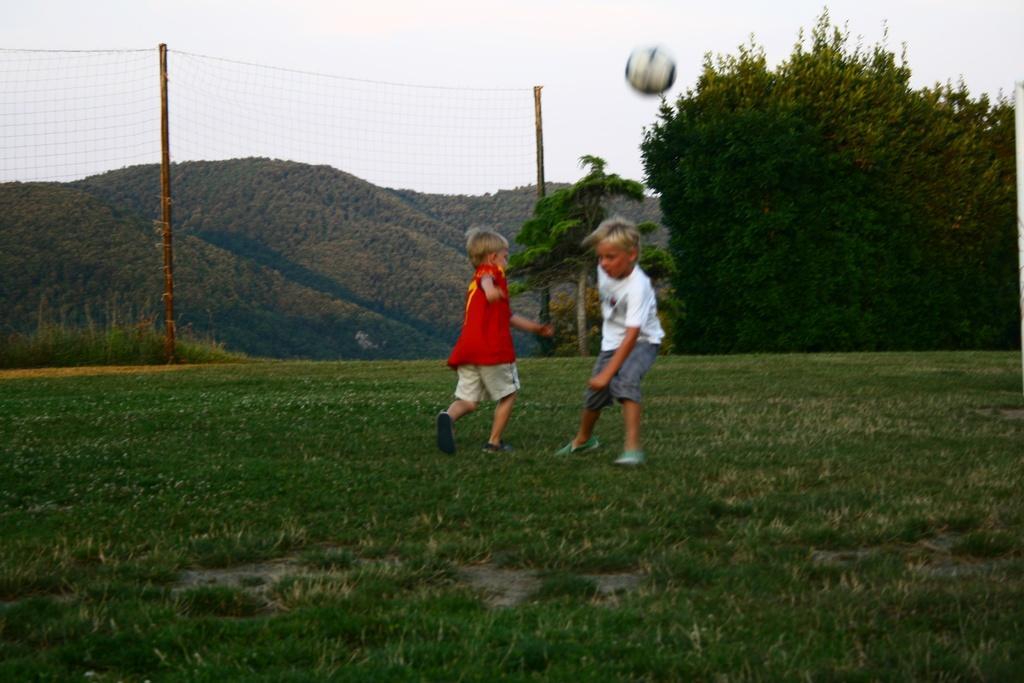In one or two sentences, can you explain what this image depicts? In this image in the center there are kids playing. In the background there is a fence and there are trees. On the ground there is grass and the sky is cloudy and there is a ball in the air. 